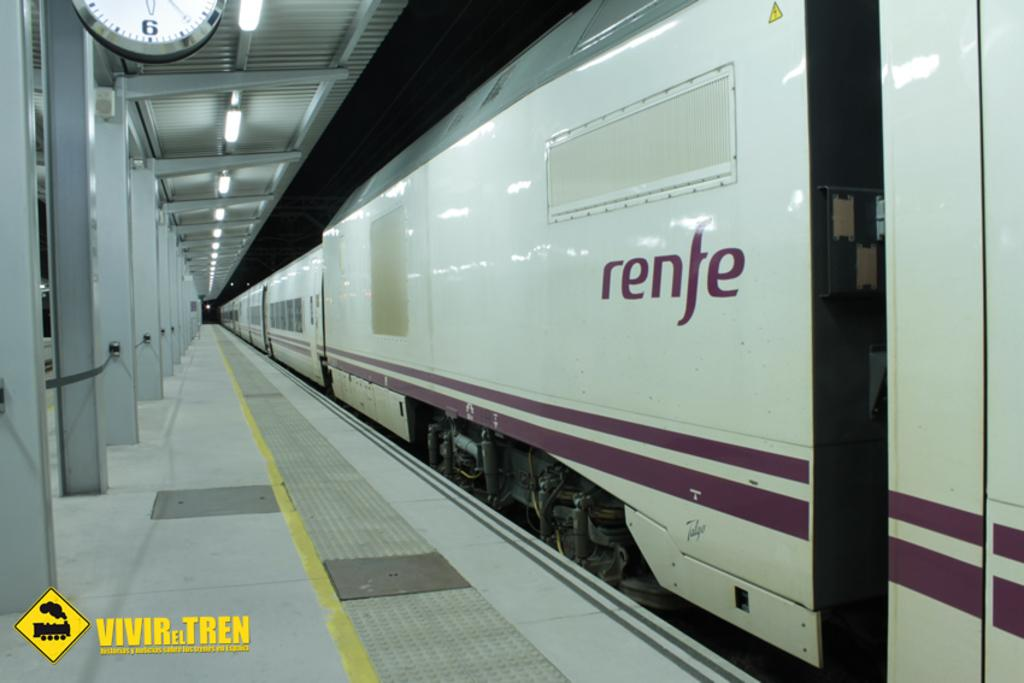<image>
Give a short and clear explanation of the subsequent image. On the side of a subaway train the word renfe is printed in red. 